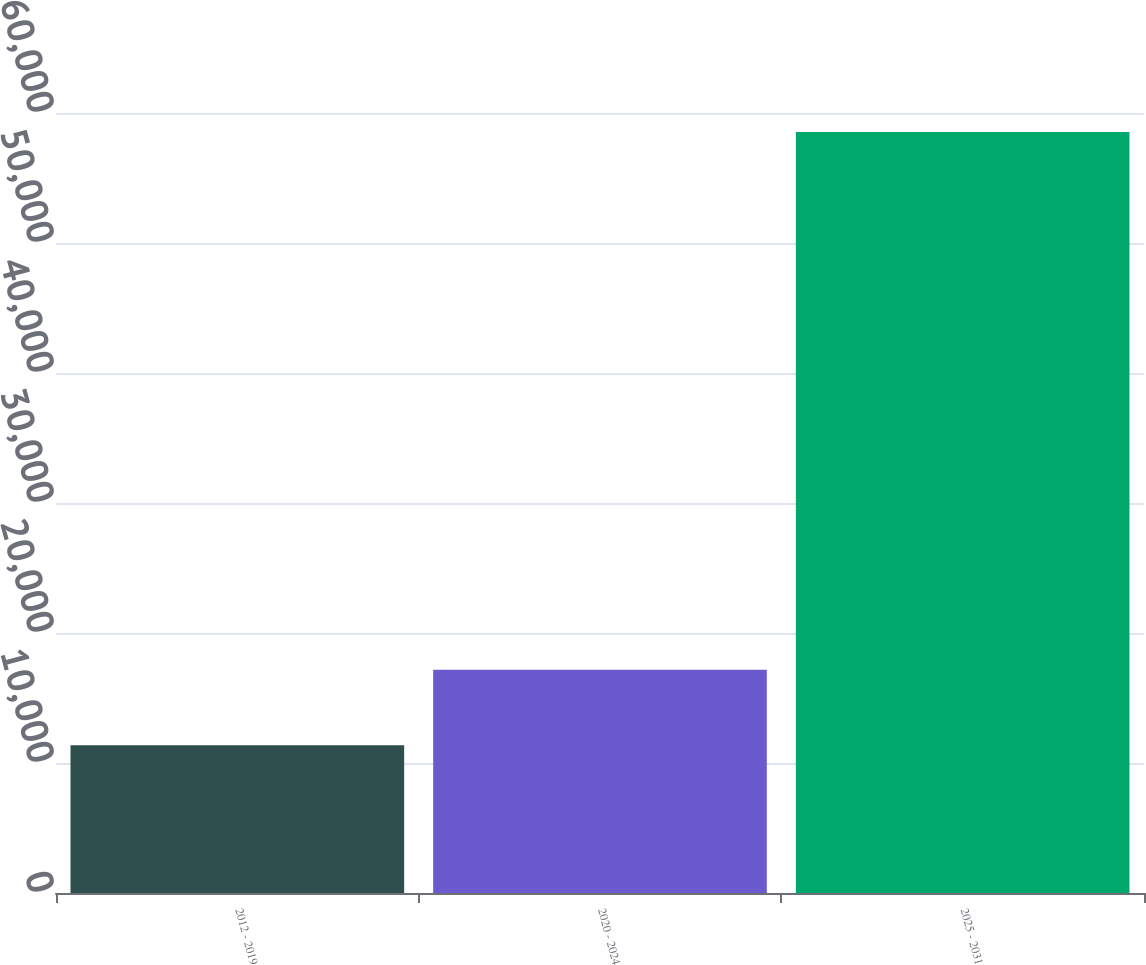Convert chart. <chart><loc_0><loc_0><loc_500><loc_500><bar_chart><fcel>2012 - 2019<fcel>2020 - 2024<fcel>2025 - 2031<nl><fcel>11374<fcel>17168<fcel>58530<nl></chart> 